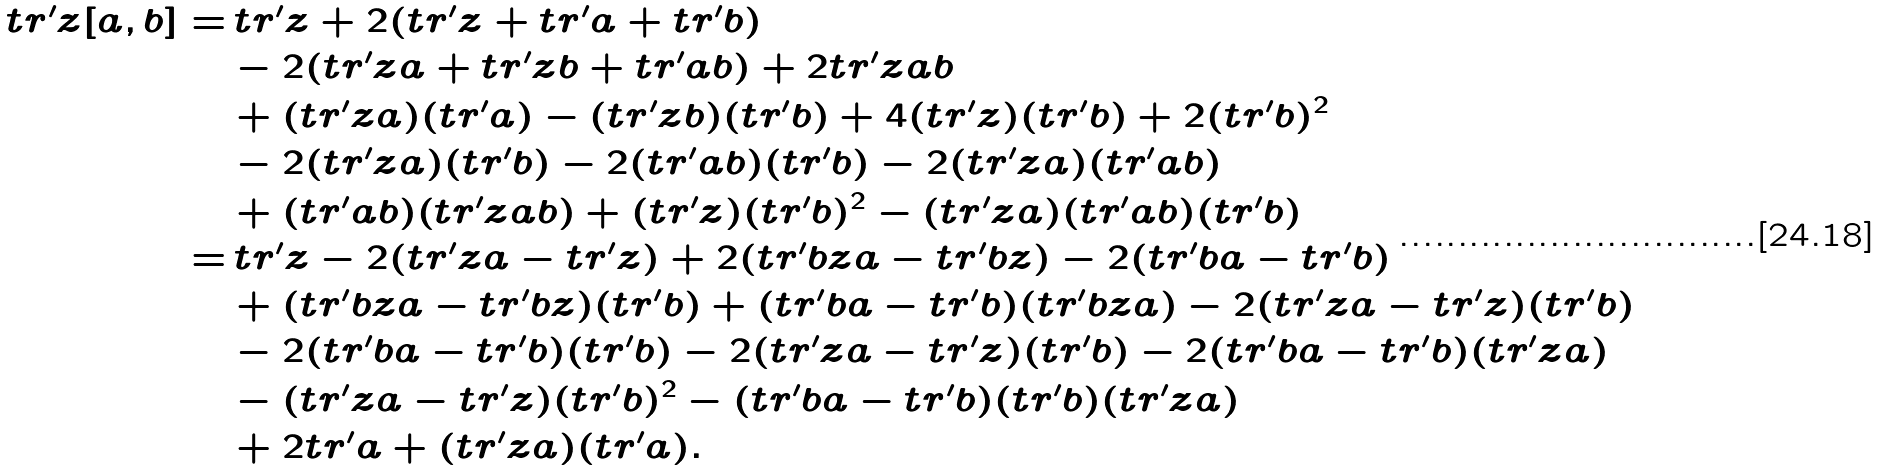<formula> <loc_0><loc_0><loc_500><loc_500>t r ^ { \prime } z [ a , b ] = & \, t r ^ { \prime } z + 2 ( t r ^ { \prime } z + t r ^ { \prime } a + t r ^ { \prime } b ) \\ & - 2 ( t r ^ { \prime } z a + t r ^ { \prime } z b + t r ^ { \prime } a b ) + 2 t r ^ { \prime } z a b \\ & + ( t r ^ { \prime } z a ) ( t r ^ { \prime } a ) - ( t r ^ { \prime } z b ) ( t r ^ { \prime } b ) + 4 ( t r ^ { \prime } z ) ( t r ^ { \prime } b ) + 2 ( t r ^ { \prime } b ) ^ { 2 } \\ & - 2 ( t r ^ { \prime } z a ) ( t r ^ { \prime } b ) - 2 ( t r ^ { \prime } a b ) ( t r ^ { \prime } b ) - 2 ( t r ^ { \prime } z a ) ( t r ^ { \prime } a b ) \\ & + ( t r ^ { \prime } a b ) ( t r ^ { \prime } z a b ) + ( t r ^ { \prime } z ) ( t r ^ { \prime } b ) ^ { 2 } - ( t r ^ { \prime } z a ) ( t r ^ { \prime } a b ) ( t r ^ { \prime } b ) \\ = & \, t r ^ { \prime } z - 2 ( t r ^ { \prime } z a - t r ^ { \prime } z ) + 2 ( t r ^ { \prime } b z a - t r ^ { \prime } b z ) - 2 ( t r ^ { \prime } b a - t r ^ { \prime } b ) \\ & + ( t r ^ { \prime } b z a - t r ^ { \prime } b z ) ( t r ^ { \prime } b ) + ( t r ^ { \prime } b a - t r ^ { \prime } b ) ( t r ^ { \prime } b z a ) - 2 ( t r ^ { \prime } z a - t r ^ { \prime } z ) ( t r ^ { \prime } b ) \\ & - 2 ( t r ^ { \prime } b a - t r ^ { \prime } b ) ( t r ^ { \prime } b ) - 2 ( t r ^ { \prime } z a - t r ^ { \prime } z ) ( t r ^ { \prime } b ) - 2 ( t r ^ { \prime } b a - t r ^ { \prime } b ) ( t r ^ { \prime } z a ) \\ & - ( t r ^ { \prime } z a - t r ^ { \prime } z ) ( t r ^ { \prime } b ) ^ { 2 } - ( t r ^ { \prime } b a - t r ^ { \prime } b ) ( t r ^ { \prime } b ) ( t r ^ { \prime } z a ) \\ & + 2 t r ^ { \prime } a + ( t r ^ { \prime } z a ) ( t r ^ { \prime } a ) .</formula> 